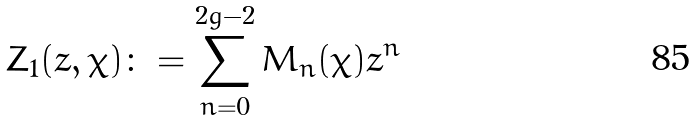Convert formula to latex. <formula><loc_0><loc_0><loc_500><loc_500>Z _ { 1 } ( z , \chi ) \colon = \sum _ { n = 0 } ^ { 2 g - 2 } M _ { n } ( \chi ) z ^ { n }</formula> 